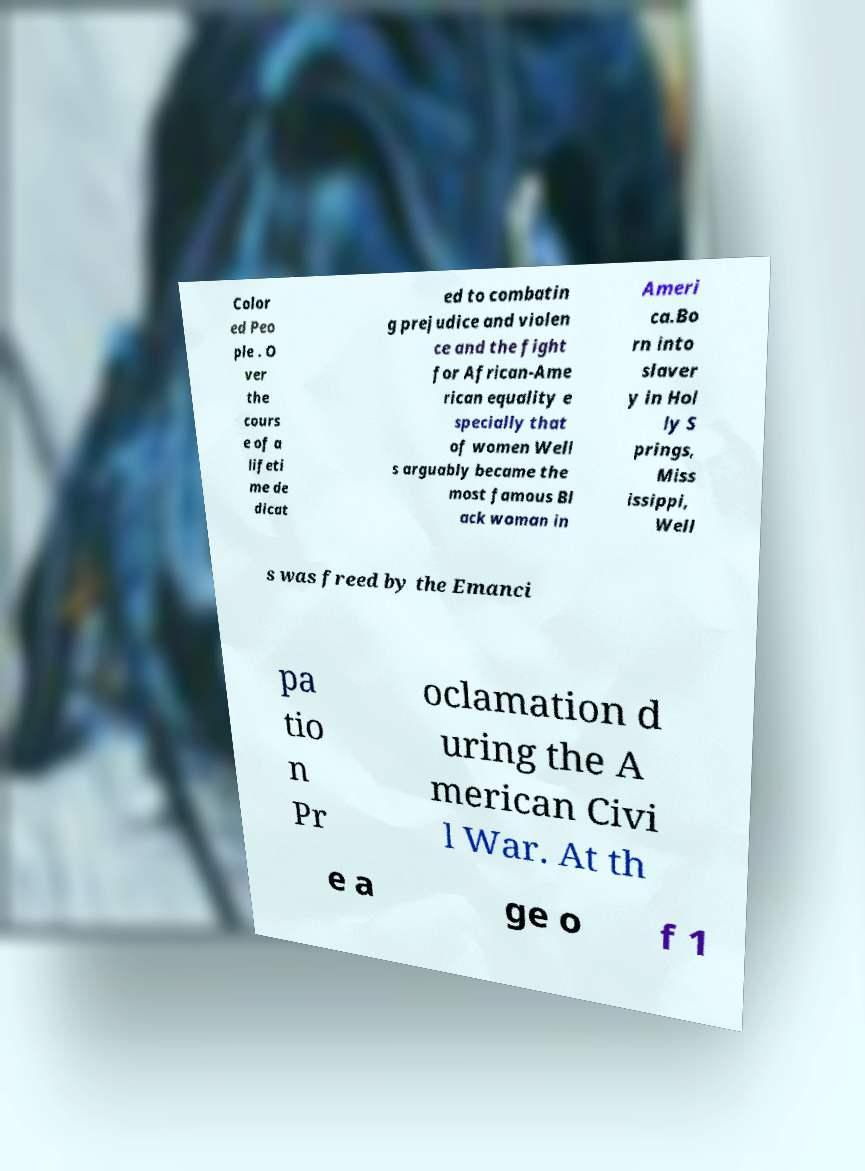What messages or text are displayed in this image? I need them in a readable, typed format. Color ed Peo ple . O ver the cours e of a lifeti me de dicat ed to combatin g prejudice and violen ce and the fight for African-Ame rican equality e specially that of women Well s arguably became the most famous Bl ack woman in Ameri ca.Bo rn into slaver y in Hol ly S prings, Miss issippi, Well s was freed by the Emanci pa tio n Pr oclamation d uring the A merican Civi l War. At th e a ge o f 1 